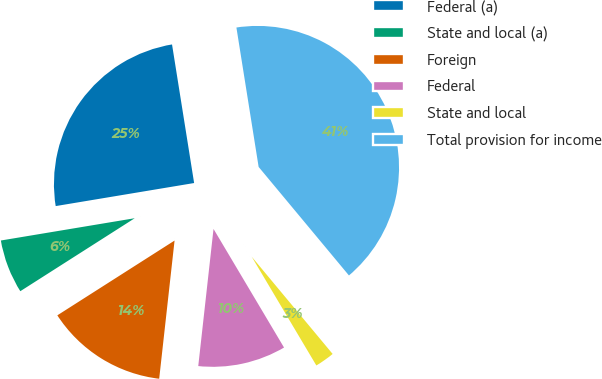Convert chart. <chart><loc_0><loc_0><loc_500><loc_500><pie_chart><fcel>Federal (a)<fcel>State and local (a)<fcel>Foreign<fcel>Federal<fcel>State and local<fcel>Total provision for income<nl><fcel>25.11%<fcel>6.41%<fcel>14.2%<fcel>10.3%<fcel>2.51%<fcel>41.47%<nl></chart> 